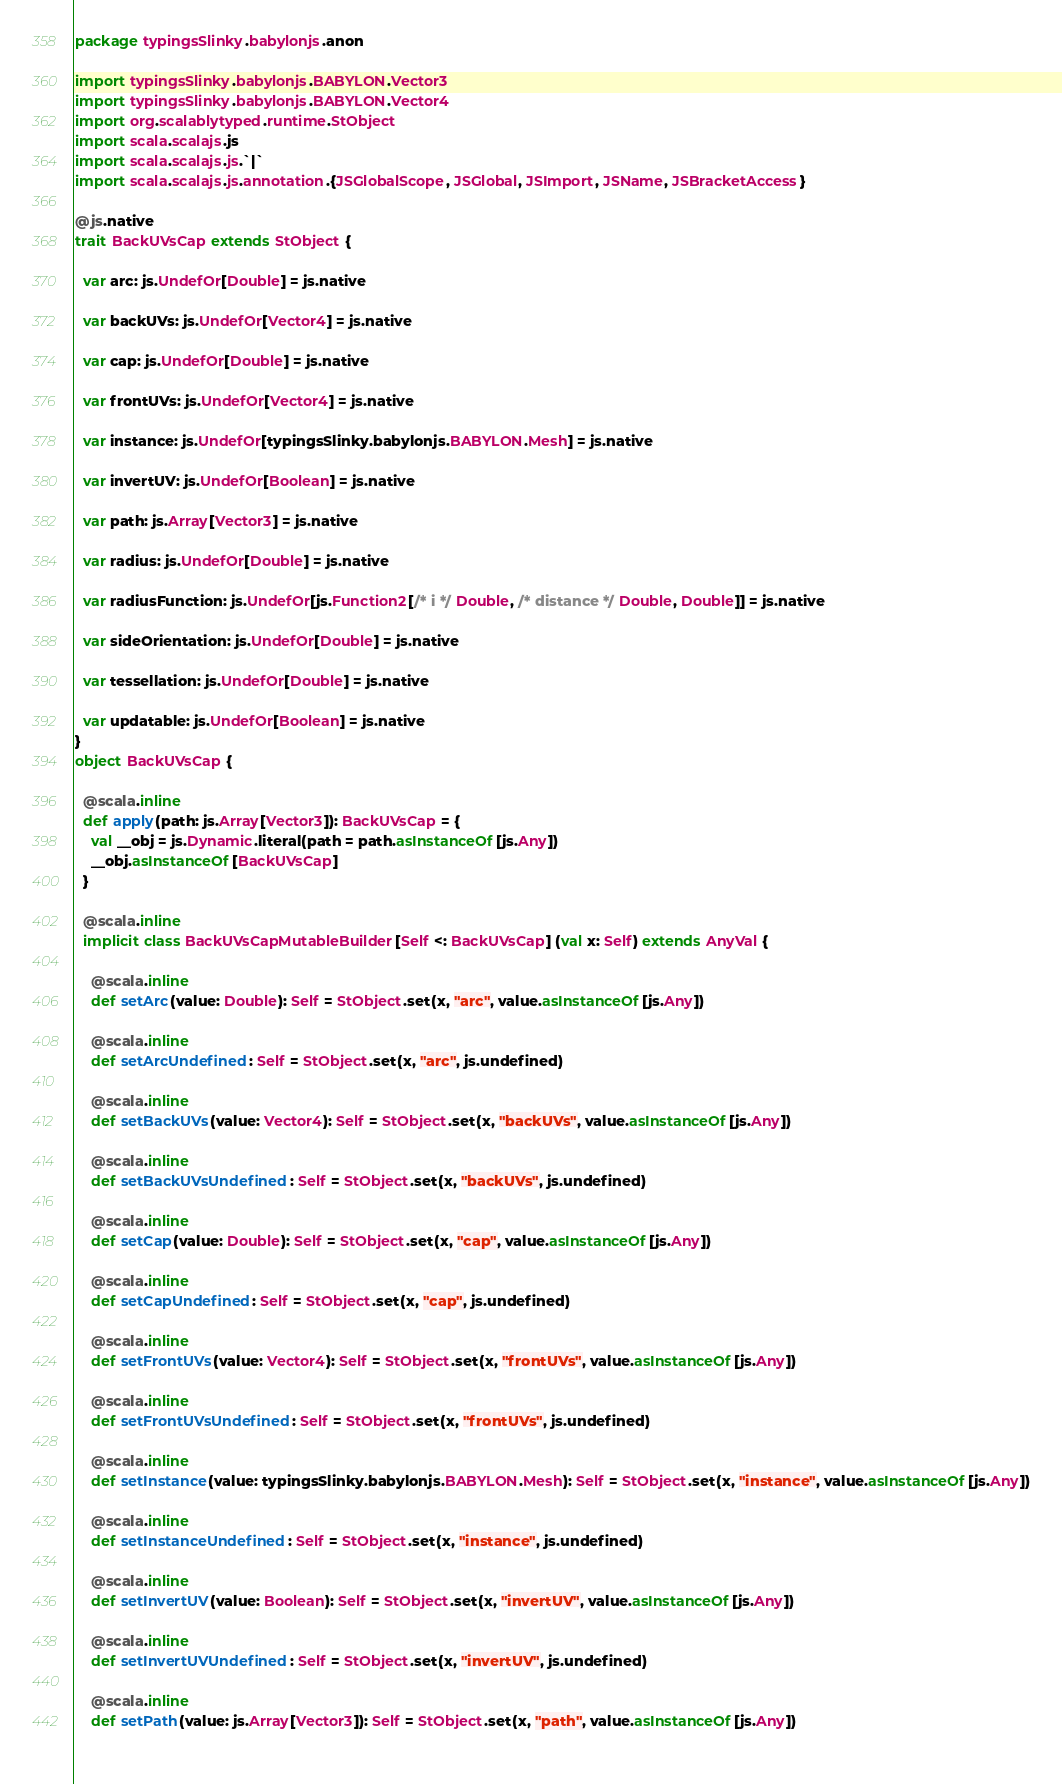<code> <loc_0><loc_0><loc_500><loc_500><_Scala_>package typingsSlinky.babylonjs.anon

import typingsSlinky.babylonjs.BABYLON.Vector3
import typingsSlinky.babylonjs.BABYLON.Vector4
import org.scalablytyped.runtime.StObject
import scala.scalajs.js
import scala.scalajs.js.`|`
import scala.scalajs.js.annotation.{JSGlobalScope, JSGlobal, JSImport, JSName, JSBracketAccess}

@js.native
trait BackUVsCap extends StObject {
  
  var arc: js.UndefOr[Double] = js.native
  
  var backUVs: js.UndefOr[Vector4] = js.native
  
  var cap: js.UndefOr[Double] = js.native
  
  var frontUVs: js.UndefOr[Vector4] = js.native
  
  var instance: js.UndefOr[typingsSlinky.babylonjs.BABYLON.Mesh] = js.native
  
  var invertUV: js.UndefOr[Boolean] = js.native
  
  var path: js.Array[Vector3] = js.native
  
  var radius: js.UndefOr[Double] = js.native
  
  var radiusFunction: js.UndefOr[js.Function2[/* i */ Double, /* distance */ Double, Double]] = js.native
  
  var sideOrientation: js.UndefOr[Double] = js.native
  
  var tessellation: js.UndefOr[Double] = js.native
  
  var updatable: js.UndefOr[Boolean] = js.native
}
object BackUVsCap {
  
  @scala.inline
  def apply(path: js.Array[Vector3]): BackUVsCap = {
    val __obj = js.Dynamic.literal(path = path.asInstanceOf[js.Any])
    __obj.asInstanceOf[BackUVsCap]
  }
  
  @scala.inline
  implicit class BackUVsCapMutableBuilder[Self <: BackUVsCap] (val x: Self) extends AnyVal {
    
    @scala.inline
    def setArc(value: Double): Self = StObject.set(x, "arc", value.asInstanceOf[js.Any])
    
    @scala.inline
    def setArcUndefined: Self = StObject.set(x, "arc", js.undefined)
    
    @scala.inline
    def setBackUVs(value: Vector4): Self = StObject.set(x, "backUVs", value.asInstanceOf[js.Any])
    
    @scala.inline
    def setBackUVsUndefined: Self = StObject.set(x, "backUVs", js.undefined)
    
    @scala.inline
    def setCap(value: Double): Self = StObject.set(x, "cap", value.asInstanceOf[js.Any])
    
    @scala.inline
    def setCapUndefined: Self = StObject.set(x, "cap", js.undefined)
    
    @scala.inline
    def setFrontUVs(value: Vector4): Self = StObject.set(x, "frontUVs", value.asInstanceOf[js.Any])
    
    @scala.inline
    def setFrontUVsUndefined: Self = StObject.set(x, "frontUVs", js.undefined)
    
    @scala.inline
    def setInstance(value: typingsSlinky.babylonjs.BABYLON.Mesh): Self = StObject.set(x, "instance", value.asInstanceOf[js.Any])
    
    @scala.inline
    def setInstanceUndefined: Self = StObject.set(x, "instance", js.undefined)
    
    @scala.inline
    def setInvertUV(value: Boolean): Self = StObject.set(x, "invertUV", value.asInstanceOf[js.Any])
    
    @scala.inline
    def setInvertUVUndefined: Self = StObject.set(x, "invertUV", js.undefined)
    
    @scala.inline
    def setPath(value: js.Array[Vector3]): Self = StObject.set(x, "path", value.asInstanceOf[js.Any])
    </code> 